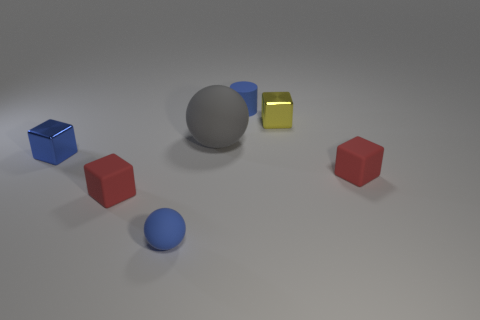Is there anything else that has the same size as the gray matte object?
Your answer should be compact. No. What number of other objects are the same color as the small sphere?
Provide a short and direct response. 2. How many objects are green things or blue blocks?
Offer a very short reply. 1. What number of objects are blue cylinders or tiny blue objects that are behind the blue shiny thing?
Your answer should be very brief. 1. Do the tiny ball and the small cylinder have the same material?
Make the answer very short. Yes. How many other objects are there of the same material as the big ball?
Keep it short and to the point. 4. Are there more yellow metal objects than gray cubes?
Offer a terse response. Yes. There is a tiny red rubber object on the right side of the gray rubber object; is its shape the same as the yellow shiny object?
Your answer should be very brief. Yes. Is the number of red cubes less than the number of objects?
Give a very brief answer. Yes. There is a cylinder that is the same size as the yellow metallic object; what material is it?
Provide a short and direct response. Rubber. 